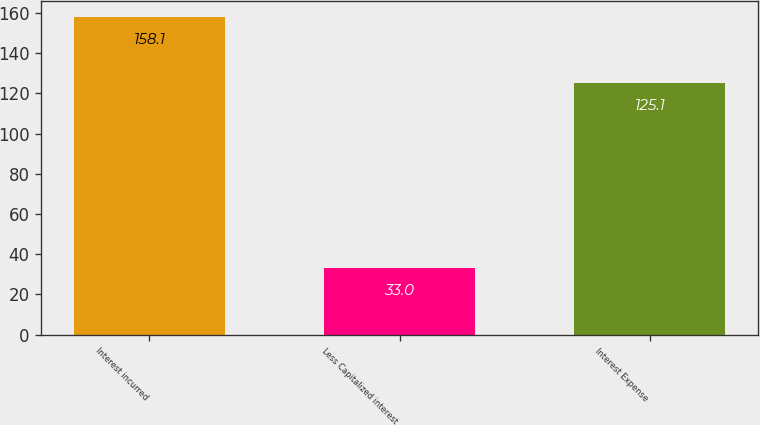<chart> <loc_0><loc_0><loc_500><loc_500><bar_chart><fcel>Interest incurred<fcel>Less Capitalized interest<fcel>Interest Expense<nl><fcel>158.1<fcel>33<fcel>125.1<nl></chart> 